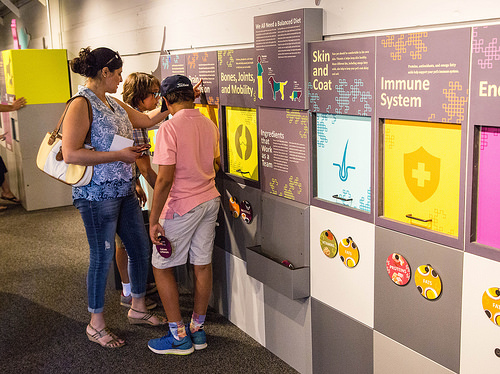<image>
Is the boy to the left of the woman? No. The boy is not to the left of the woman. From this viewpoint, they have a different horizontal relationship. 